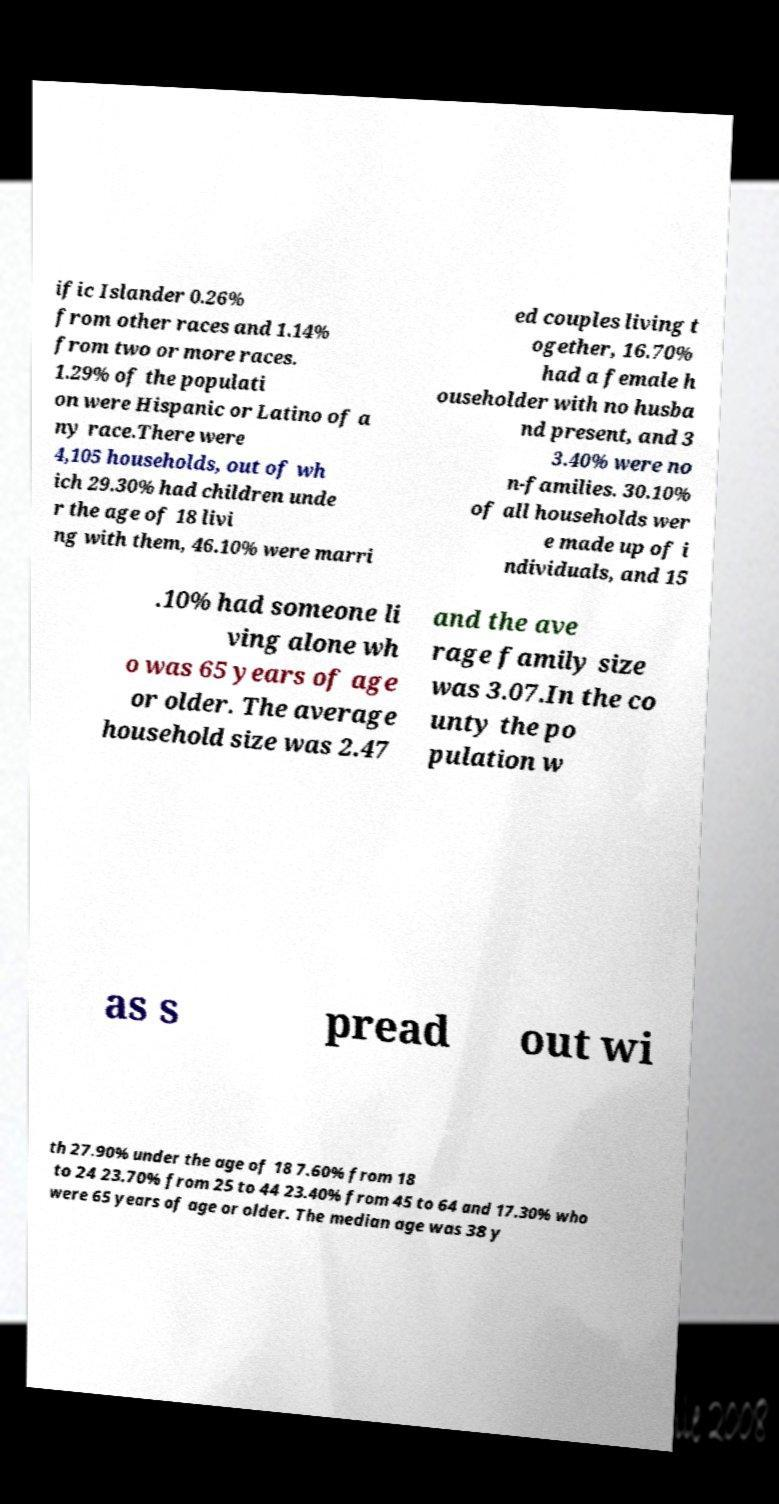Please read and relay the text visible in this image. What does it say? ific Islander 0.26% from other races and 1.14% from two or more races. 1.29% of the populati on were Hispanic or Latino of a ny race.There were 4,105 households, out of wh ich 29.30% had children unde r the age of 18 livi ng with them, 46.10% were marri ed couples living t ogether, 16.70% had a female h ouseholder with no husba nd present, and 3 3.40% were no n-families. 30.10% of all households wer e made up of i ndividuals, and 15 .10% had someone li ving alone wh o was 65 years of age or older. The average household size was 2.47 and the ave rage family size was 3.07.In the co unty the po pulation w as s pread out wi th 27.90% under the age of 18 7.60% from 18 to 24 23.70% from 25 to 44 23.40% from 45 to 64 and 17.30% who were 65 years of age or older. The median age was 38 y 